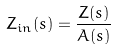<formula> <loc_0><loc_0><loc_500><loc_500>Z _ { i n } ( s ) = \frac { Z ( s ) } { A ( s ) }</formula> 